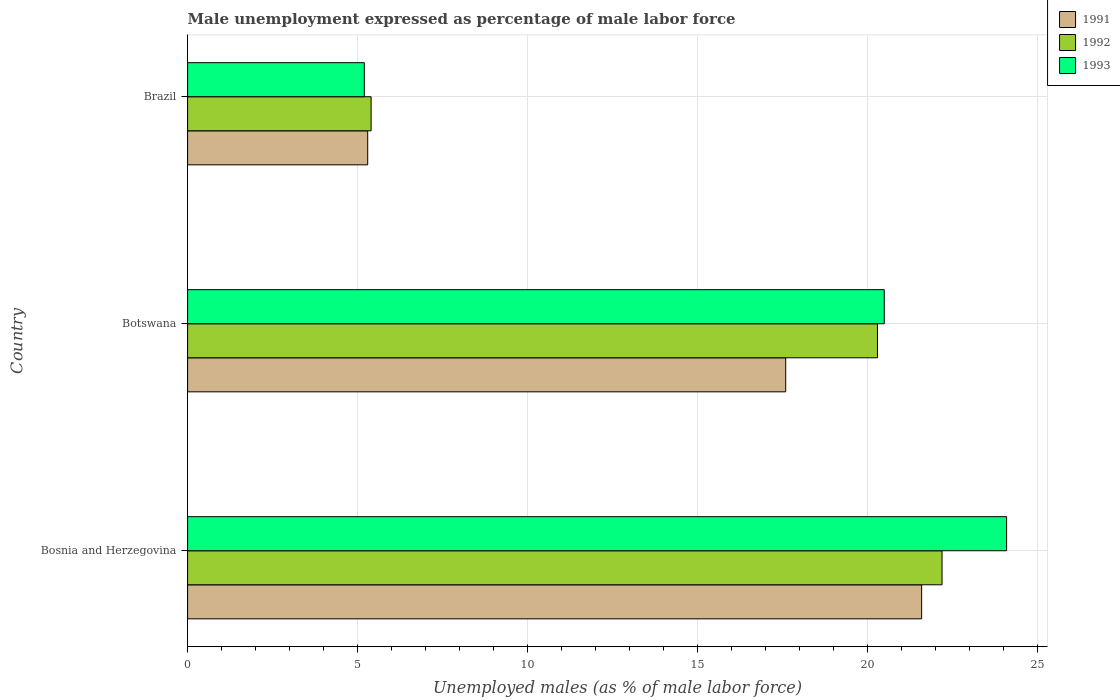How many bars are there on the 3rd tick from the top?
Provide a succinct answer. 3. How many bars are there on the 3rd tick from the bottom?
Give a very brief answer. 3. What is the label of the 2nd group of bars from the top?
Give a very brief answer. Botswana. What is the unemployment in males in in 1991 in Brazil?
Offer a very short reply. 5.3. Across all countries, what is the maximum unemployment in males in in 1993?
Your response must be concise. 24.1. Across all countries, what is the minimum unemployment in males in in 1993?
Offer a terse response. 5.2. In which country was the unemployment in males in in 1993 maximum?
Give a very brief answer. Bosnia and Herzegovina. What is the total unemployment in males in in 1993 in the graph?
Offer a very short reply. 49.8. What is the difference between the unemployment in males in in 1993 in Bosnia and Herzegovina and that in Brazil?
Your response must be concise. 18.9. What is the difference between the unemployment in males in in 1991 in Bosnia and Herzegovina and the unemployment in males in in 1992 in Brazil?
Offer a terse response. 16.2. What is the average unemployment in males in in 1992 per country?
Give a very brief answer. 15.97. What is the difference between the unemployment in males in in 1991 and unemployment in males in in 1992 in Bosnia and Herzegovina?
Ensure brevity in your answer.  -0.6. In how many countries, is the unemployment in males in in 1992 greater than 1 %?
Your answer should be compact. 3. What is the ratio of the unemployment in males in in 1992 in Bosnia and Herzegovina to that in Botswana?
Ensure brevity in your answer.  1.09. What is the difference between the highest and the second highest unemployment in males in in 1991?
Your answer should be compact. 4. What is the difference between the highest and the lowest unemployment in males in in 1991?
Your answer should be compact. 16.3. What does the 3rd bar from the bottom in Brazil represents?
Give a very brief answer. 1993. Is it the case that in every country, the sum of the unemployment in males in in 1991 and unemployment in males in in 1993 is greater than the unemployment in males in in 1992?
Offer a very short reply. Yes. How many bars are there?
Make the answer very short. 9. How many countries are there in the graph?
Provide a short and direct response. 3. Are the values on the major ticks of X-axis written in scientific E-notation?
Provide a short and direct response. No. Does the graph contain any zero values?
Provide a succinct answer. No. Does the graph contain grids?
Ensure brevity in your answer.  Yes. Where does the legend appear in the graph?
Offer a very short reply. Top right. How are the legend labels stacked?
Offer a very short reply. Vertical. What is the title of the graph?
Offer a very short reply. Male unemployment expressed as percentage of male labor force. What is the label or title of the X-axis?
Your answer should be very brief. Unemployed males (as % of male labor force). What is the Unemployed males (as % of male labor force) of 1991 in Bosnia and Herzegovina?
Give a very brief answer. 21.6. What is the Unemployed males (as % of male labor force) in 1992 in Bosnia and Herzegovina?
Give a very brief answer. 22.2. What is the Unemployed males (as % of male labor force) of 1993 in Bosnia and Herzegovina?
Make the answer very short. 24.1. What is the Unemployed males (as % of male labor force) of 1991 in Botswana?
Offer a terse response. 17.6. What is the Unemployed males (as % of male labor force) in 1992 in Botswana?
Provide a short and direct response. 20.3. What is the Unemployed males (as % of male labor force) in 1991 in Brazil?
Ensure brevity in your answer.  5.3. What is the Unemployed males (as % of male labor force) in 1992 in Brazil?
Offer a very short reply. 5.4. What is the Unemployed males (as % of male labor force) of 1993 in Brazil?
Your answer should be very brief. 5.2. Across all countries, what is the maximum Unemployed males (as % of male labor force) of 1991?
Your answer should be compact. 21.6. Across all countries, what is the maximum Unemployed males (as % of male labor force) in 1992?
Make the answer very short. 22.2. Across all countries, what is the maximum Unemployed males (as % of male labor force) of 1993?
Give a very brief answer. 24.1. Across all countries, what is the minimum Unemployed males (as % of male labor force) in 1991?
Keep it short and to the point. 5.3. Across all countries, what is the minimum Unemployed males (as % of male labor force) in 1992?
Provide a succinct answer. 5.4. Across all countries, what is the minimum Unemployed males (as % of male labor force) of 1993?
Give a very brief answer. 5.2. What is the total Unemployed males (as % of male labor force) in 1991 in the graph?
Your answer should be very brief. 44.5. What is the total Unemployed males (as % of male labor force) in 1992 in the graph?
Make the answer very short. 47.9. What is the total Unemployed males (as % of male labor force) of 1993 in the graph?
Your answer should be compact. 49.8. What is the difference between the Unemployed males (as % of male labor force) in 1992 in Bosnia and Herzegovina and that in Botswana?
Give a very brief answer. 1.9. What is the difference between the Unemployed males (as % of male labor force) of 1993 in Bosnia and Herzegovina and that in Botswana?
Provide a short and direct response. 3.6. What is the difference between the Unemployed males (as % of male labor force) of 1991 in Bosnia and Herzegovina and that in Brazil?
Give a very brief answer. 16.3. What is the difference between the Unemployed males (as % of male labor force) of 1992 in Bosnia and Herzegovina and that in Brazil?
Provide a short and direct response. 16.8. What is the difference between the Unemployed males (as % of male labor force) of 1993 in Bosnia and Herzegovina and that in Brazil?
Make the answer very short. 18.9. What is the difference between the Unemployed males (as % of male labor force) of 1993 in Botswana and that in Brazil?
Provide a succinct answer. 15.3. What is the difference between the Unemployed males (as % of male labor force) in 1991 in Bosnia and Herzegovina and the Unemployed males (as % of male labor force) in 1992 in Brazil?
Ensure brevity in your answer.  16.2. What is the difference between the Unemployed males (as % of male labor force) in 1991 in Bosnia and Herzegovina and the Unemployed males (as % of male labor force) in 1993 in Brazil?
Your answer should be compact. 16.4. What is the difference between the Unemployed males (as % of male labor force) in 1991 in Botswana and the Unemployed males (as % of male labor force) in 1993 in Brazil?
Offer a terse response. 12.4. What is the difference between the Unemployed males (as % of male labor force) in 1992 in Botswana and the Unemployed males (as % of male labor force) in 1993 in Brazil?
Your answer should be very brief. 15.1. What is the average Unemployed males (as % of male labor force) in 1991 per country?
Offer a very short reply. 14.83. What is the average Unemployed males (as % of male labor force) in 1992 per country?
Keep it short and to the point. 15.97. What is the difference between the Unemployed males (as % of male labor force) in 1991 and Unemployed males (as % of male labor force) in 1992 in Bosnia and Herzegovina?
Your response must be concise. -0.6. What is the difference between the Unemployed males (as % of male labor force) of 1991 and Unemployed males (as % of male labor force) of 1993 in Bosnia and Herzegovina?
Offer a terse response. -2.5. What is the difference between the Unemployed males (as % of male labor force) in 1992 and Unemployed males (as % of male labor force) in 1993 in Bosnia and Herzegovina?
Offer a very short reply. -1.9. What is the difference between the Unemployed males (as % of male labor force) of 1992 and Unemployed males (as % of male labor force) of 1993 in Botswana?
Ensure brevity in your answer.  -0.2. What is the difference between the Unemployed males (as % of male labor force) in 1991 and Unemployed males (as % of male labor force) in 1992 in Brazil?
Keep it short and to the point. -0.1. What is the ratio of the Unemployed males (as % of male labor force) of 1991 in Bosnia and Herzegovina to that in Botswana?
Make the answer very short. 1.23. What is the ratio of the Unemployed males (as % of male labor force) of 1992 in Bosnia and Herzegovina to that in Botswana?
Provide a short and direct response. 1.09. What is the ratio of the Unemployed males (as % of male labor force) in 1993 in Bosnia and Herzegovina to that in Botswana?
Your answer should be very brief. 1.18. What is the ratio of the Unemployed males (as % of male labor force) in 1991 in Bosnia and Herzegovina to that in Brazil?
Your answer should be compact. 4.08. What is the ratio of the Unemployed males (as % of male labor force) of 1992 in Bosnia and Herzegovina to that in Brazil?
Your answer should be compact. 4.11. What is the ratio of the Unemployed males (as % of male labor force) of 1993 in Bosnia and Herzegovina to that in Brazil?
Provide a short and direct response. 4.63. What is the ratio of the Unemployed males (as % of male labor force) of 1991 in Botswana to that in Brazil?
Your response must be concise. 3.32. What is the ratio of the Unemployed males (as % of male labor force) of 1992 in Botswana to that in Brazil?
Make the answer very short. 3.76. What is the ratio of the Unemployed males (as % of male labor force) in 1993 in Botswana to that in Brazil?
Make the answer very short. 3.94. What is the difference between the highest and the second highest Unemployed males (as % of male labor force) of 1993?
Your answer should be very brief. 3.6. What is the difference between the highest and the lowest Unemployed males (as % of male labor force) in 1993?
Your response must be concise. 18.9. 